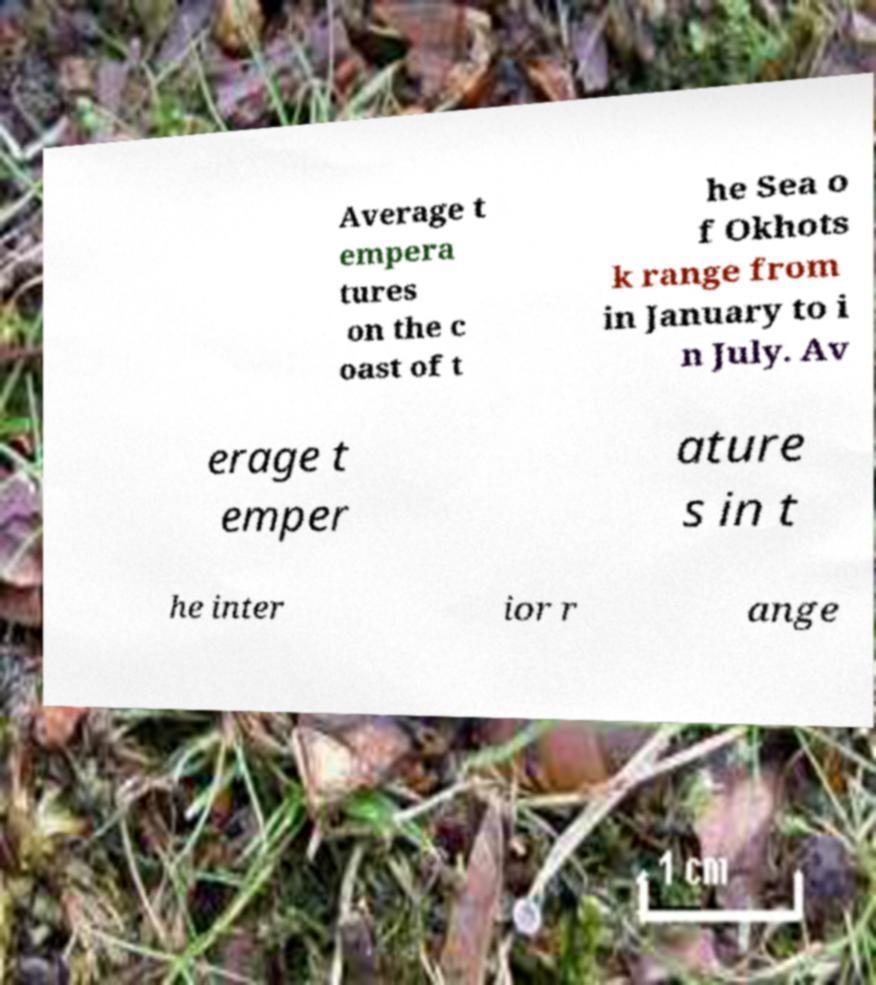What messages or text are displayed in this image? I need them in a readable, typed format. Average t empera tures on the c oast of t he Sea o f Okhots k range from in January to i n July. Av erage t emper ature s in t he inter ior r ange 